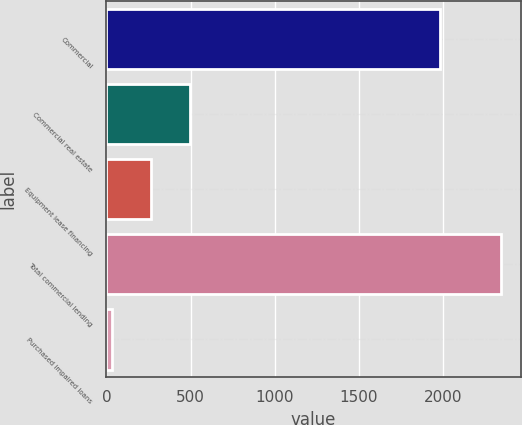<chart> <loc_0><loc_0><loc_500><loc_500><bar_chart><fcel>Commercial<fcel>Commercial real estate<fcel>Equipment lease financing<fcel>Total commercial lending<fcel>Purchased impaired loans<nl><fcel>1984<fcel>494<fcel>262.5<fcel>2346<fcel>31<nl></chart> 